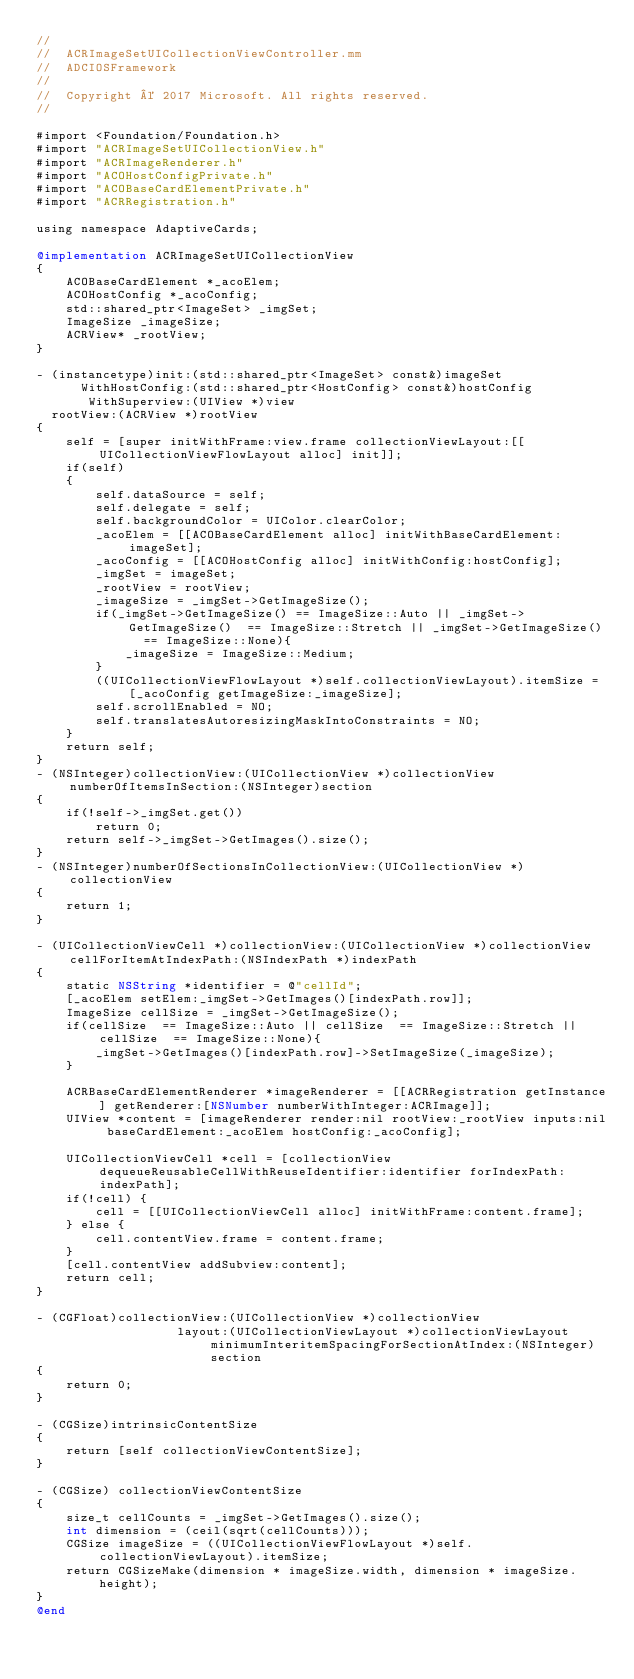Convert code to text. <code><loc_0><loc_0><loc_500><loc_500><_ObjectiveC_>//
//  ACRImageSetUICollectionViewController.mm
//  ADCIOSFramework
//
//  Copyright © 2017 Microsoft. All rights reserved.
//

#import <Foundation/Foundation.h>
#import "ACRImageSetUICollectionView.h"
#import "ACRImageRenderer.h"
#import "ACOHostConfigPrivate.h"
#import "ACOBaseCardElementPrivate.h"
#import "ACRRegistration.h"

using namespace AdaptiveCards;

@implementation ACRImageSetUICollectionView
{
    ACOBaseCardElement *_acoElem;
    ACOHostConfig *_acoConfig;
    std::shared_ptr<ImageSet> _imgSet;
    ImageSize _imageSize;
    ACRView* _rootView;
}

- (instancetype)init:(std::shared_ptr<ImageSet> const&)imageSet
      WithHostConfig:(std::shared_ptr<HostConfig> const&)hostConfig
       WithSuperview:(UIView *)view
  rootView:(ACRView *)rootView
{
    self = [super initWithFrame:view.frame collectionViewLayout:[[UICollectionViewFlowLayout alloc] init]];
    if(self)
    {
        self.dataSource = self;
        self.delegate = self;
        self.backgroundColor = UIColor.clearColor;
        _acoElem = [[ACOBaseCardElement alloc] initWithBaseCardElement:imageSet];
        _acoConfig = [[ACOHostConfig alloc] initWithConfig:hostConfig];
        _imgSet = imageSet;
        _rootView = rootView;
        _imageSize = _imgSet->GetImageSize();
        if(_imgSet->GetImageSize() == ImageSize::Auto || _imgSet->GetImageSize()  == ImageSize::Stretch || _imgSet->GetImageSize()  == ImageSize::None){
            _imageSize = ImageSize::Medium;
        }
        ((UICollectionViewFlowLayout *)self.collectionViewLayout).itemSize = [_acoConfig getImageSize:_imageSize];
        self.scrollEnabled = NO;
        self.translatesAutoresizingMaskIntoConstraints = NO;
    }
    return self;
}
- (NSInteger)collectionView:(UICollectionView *)collectionView numberOfItemsInSection:(NSInteger)section
{
    if(!self->_imgSet.get())
        return 0;
    return self->_imgSet->GetImages().size();
}
- (NSInteger)numberOfSectionsInCollectionView:(UICollectionView *)collectionView
{
    return 1;
}

- (UICollectionViewCell *)collectionView:(UICollectionView *)collectionView cellForItemAtIndexPath:(NSIndexPath *)indexPath
{
    static NSString *identifier = @"cellId";
    [_acoElem setElem:_imgSet->GetImages()[indexPath.row]];
    ImageSize cellSize = _imgSet->GetImageSize();
    if(cellSize  == ImageSize::Auto || cellSize  == ImageSize::Stretch || cellSize  == ImageSize::None){
        _imgSet->GetImages()[indexPath.row]->SetImageSize(_imageSize);
    }

    ACRBaseCardElementRenderer *imageRenderer = [[ACRRegistration getInstance] getRenderer:[NSNumber numberWithInteger:ACRImage]];
    UIView *content = [imageRenderer render:nil rootView:_rootView inputs:nil baseCardElement:_acoElem hostConfig:_acoConfig];

    UICollectionViewCell *cell = [collectionView dequeueReusableCellWithReuseIdentifier:identifier forIndexPath:indexPath];
    if(!cell) {
        cell = [[UICollectionViewCell alloc] initWithFrame:content.frame];
    } else {
        cell.contentView.frame = content.frame;
    }
    [cell.contentView addSubview:content];
    return cell;
}

- (CGFloat)collectionView:(UICollectionView *)collectionView
                   layout:(UICollectionViewLayout *)collectionViewLayout minimumInteritemSpacingForSectionAtIndex:(NSInteger)section
{
    return 0;
}

- (CGSize)intrinsicContentSize
{
    return [self collectionViewContentSize];
}

- (CGSize) collectionViewContentSize
{
    size_t cellCounts = _imgSet->GetImages().size();
    int dimension = (ceil(sqrt(cellCounts)));
    CGSize imageSize = ((UICollectionViewFlowLayout *)self.collectionViewLayout).itemSize;
    return CGSizeMake(dimension * imageSize.width, dimension * imageSize.height);
}
@end
</code> 